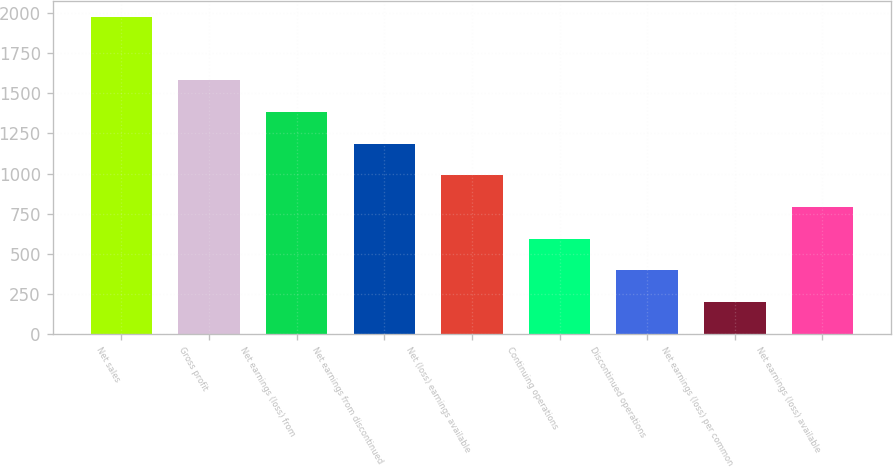<chart> <loc_0><loc_0><loc_500><loc_500><bar_chart><fcel>Net sales<fcel>Gross profit<fcel>Net earnings (loss) from<fcel>Net earnings from discontinued<fcel>Net (loss) earnings available<fcel>Continuing operations<fcel>Discontinued operations<fcel>Net earnings (loss) per common<fcel>Net earnings (loss) available<nl><fcel>1977.8<fcel>1582.43<fcel>1384.73<fcel>1187.03<fcel>989.33<fcel>593.93<fcel>396.23<fcel>198.53<fcel>791.63<nl></chart> 